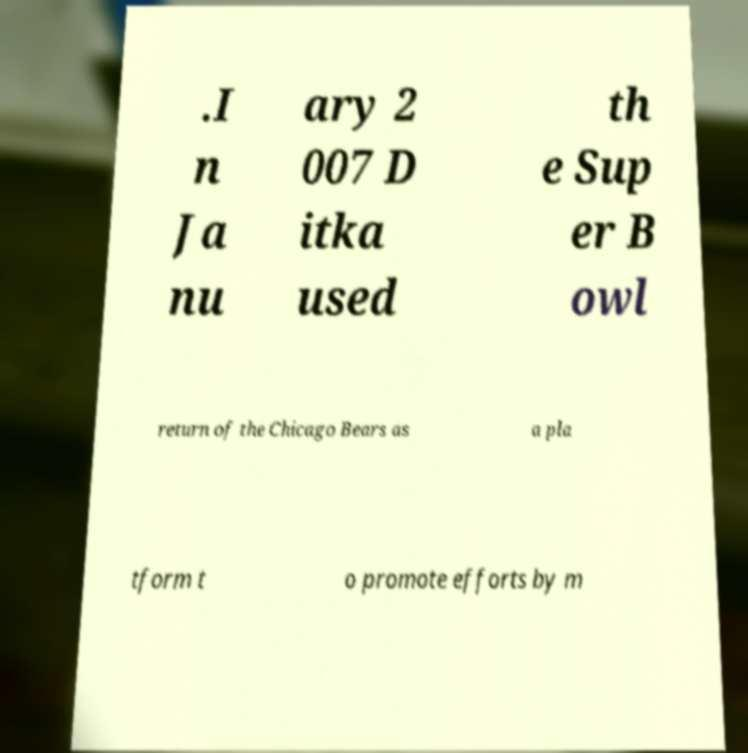What messages or text are displayed in this image? I need them in a readable, typed format. .I n Ja nu ary 2 007 D itka used th e Sup er B owl return of the Chicago Bears as a pla tform t o promote efforts by m 